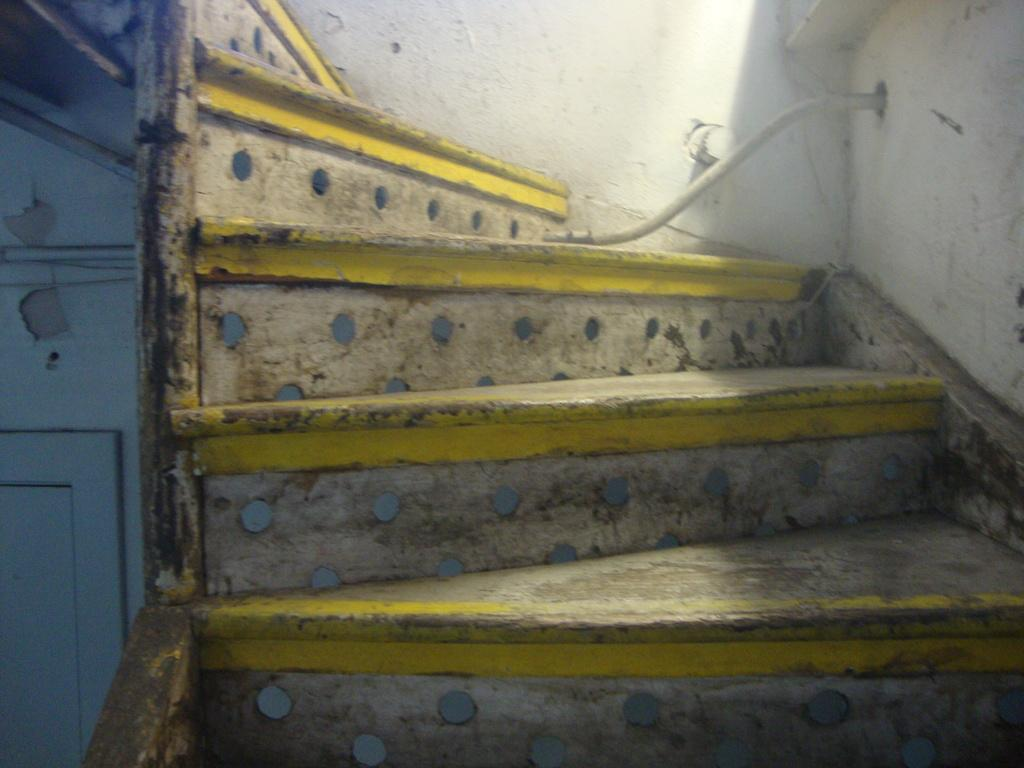What type of architectural feature is present in the image? There are stairs in the image. Where is the wooden door located in the image? The wooden door is on the left side of the image. What can be seen coming out of the wall in the image? There is a cable coming out of the wall in the image. How many lizards can be seen crawling on the sand in the image? There are no lizards or sand present in the image. What type of test is being conducted in the image? There is no test being conducted in the image; it features stairs, a wooden door, and a cable coming out of the wall. 